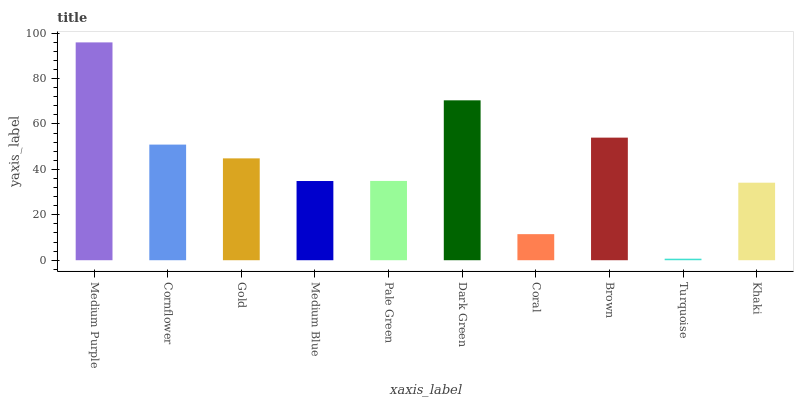Is Turquoise the minimum?
Answer yes or no. Yes. Is Medium Purple the maximum?
Answer yes or no. Yes. Is Cornflower the minimum?
Answer yes or no. No. Is Cornflower the maximum?
Answer yes or no. No. Is Medium Purple greater than Cornflower?
Answer yes or no. Yes. Is Cornflower less than Medium Purple?
Answer yes or no. Yes. Is Cornflower greater than Medium Purple?
Answer yes or no. No. Is Medium Purple less than Cornflower?
Answer yes or no. No. Is Gold the high median?
Answer yes or no. Yes. Is Pale Green the low median?
Answer yes or no. Yes. Is Dark Green the high median?
Answer yes or no. No. Is Coral the low median?
Answer yes or no. No. 